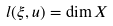Convert formula to latex. <formula><loc_0><loc_0><loc_500><loc_500>l ( \xi , u ) = \dim X</formula> 